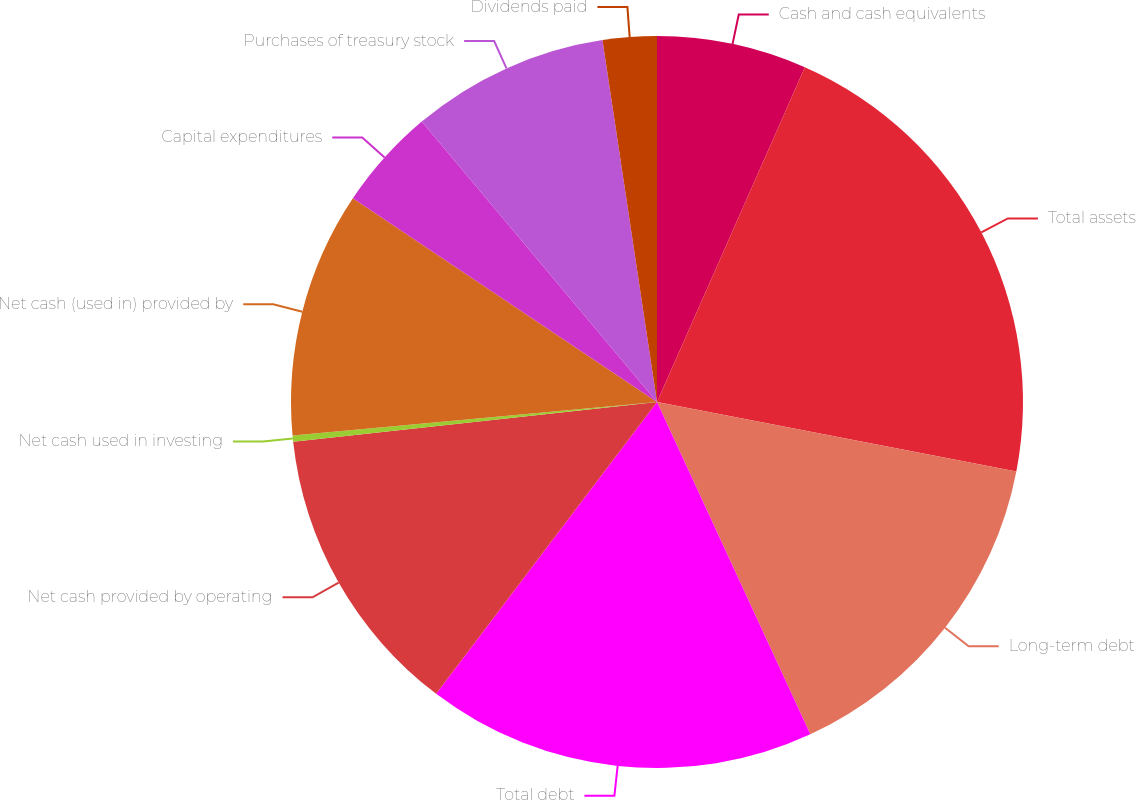Convert chart. <chart><loc_0><loc_0><loc_500><loc_500><pie_chart><fcel>Cash and cash equivalents<fcel>Total assets<fcel>Long-term debt<fcel>Total debt<fcel>Net cash provided by operating<fcel>Net cash used in investing<fcel>Net cash (used in) provided by<fcel>Capital expenditures<fcel>Purchases of treasury stock<fcel>Dividends paid<nl><fcel>6.62%<fcel>21.42%<fcel>15.08%<fcel>17.19%<fcel>12.96%<fcel>0.27%<fcel>10.85%<fcel>4.5%<fcel>8.73%<fcel>2.38%<nl></chart> 